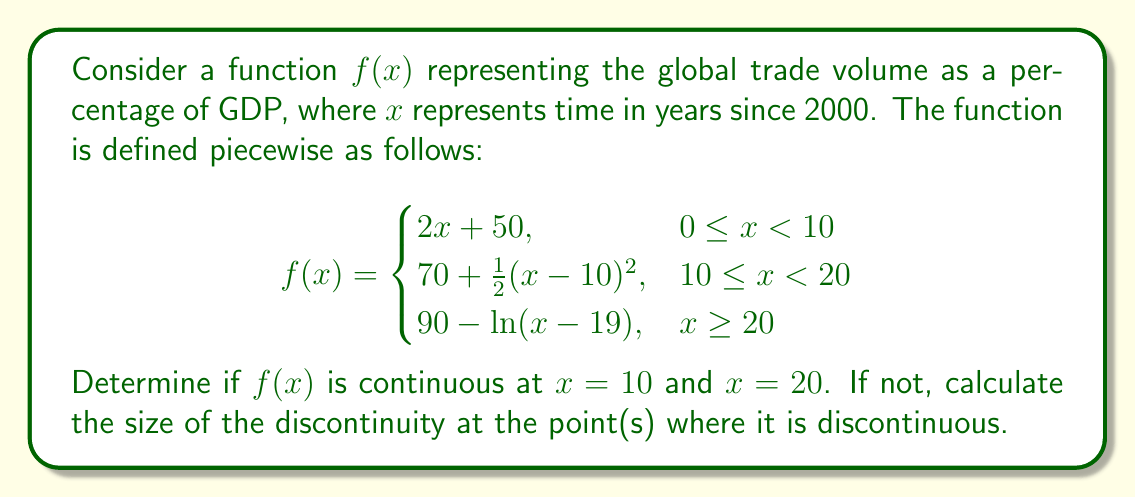Teach me how to tackle this problem. To determine if $f(x)$ is continuous at $x = 10$ and $x = 20$, we need to check three conditions at each point:
1. The function is defined at the point.
2. The limit of the function exists as we approach the point from both sides.
3. The limit equals the function value at that point.

For $x = 10$:

1. $f(10)$ is defined in both pieces of the function.
2. Left-hand limit: 
   $\lim_{x \to 10^-} f(x) = \lim_{x \to 10^-} (2x + 50) = 2(10) + 50 = 70$
   Right-hand limit: 
   $\lim_{x \to 10^+} f(x) = \lim_{x \to 10^+} (70 + \frac{1}{2}(x-10)^2) = 70 + \frac{1}{2}(0)^2 = 70$
3. $f(10) = 70 + \frac{1}{2}(10-10)^2 = 70$

All three conditions are met, so $f(x)$ is continuous at $x = 10$.

For $x = 20$:

1. $f(20)$ is defined in both pieces of the function.
2. Left-hand limit:
   $\lim_{x \to 20^-} f(x) = \lim_{x \to 20^-} (70 + \frac{1}{2}(x-10)^2) = 70 + \frac{1}{2}(10)^2 = 120$
   Right-hand limit:
   $\lim_{x \to 20^+} f(x) = \lim_{x \to 20^+} (90 - \ln(x-19)) = 90 - \ln(1) = 90$
3. $f(20) = 90 - \ln(20-19) = 90 - \ln(1) = 90$

The left-hand limit does not equal the right-hand limit, so $f(x)$ is not continuous at $x = 20$.

The size of the discontinuity at $x = 20$ is:
$|\lim_{x \to 20^-} f(x) - \lim_{x \to 20^+} f(x)| = |120 - 90| = 30$
Answer: $f(x)$ is continuous at $x = 10$ but discontinuous at $x = 20$. The size of the discontinuity at $x = 20$ is 30. 